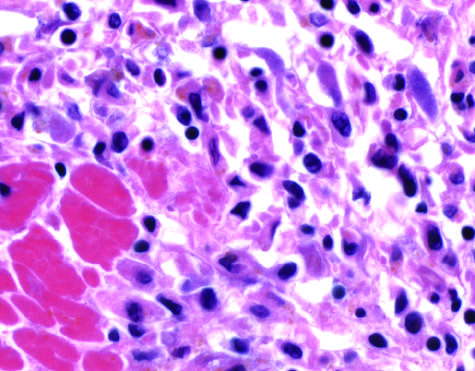do the photomicrographs show an inflammatory reaction in the myocardium after ischemic necrosis infarction?
Answer the question using a single word or phrase. Yes 